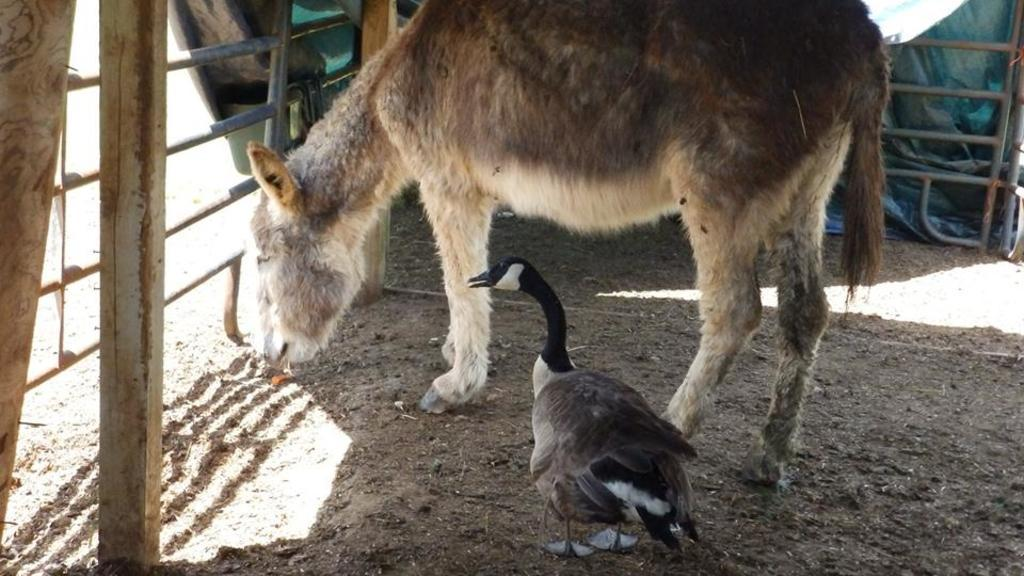What type of animal is in the image? There is an animal in the image, but the specific type cannot be determined from the provided facts. What other living creature is in the image? There is a bird in the image. What can be seen beneath the animal and bird? The ground is visible in the image. What type of barrier is in the image? There is a fence in the image. What is covering something in the image? There is a cover in the image. What vertical structure is in the image? There is a pole in the image. What object is on the left side of the image? The specific object cannot be determined from the provided facts. What type of produce is being harvested in the image? There is no produce or harvesting activity present in the image. 